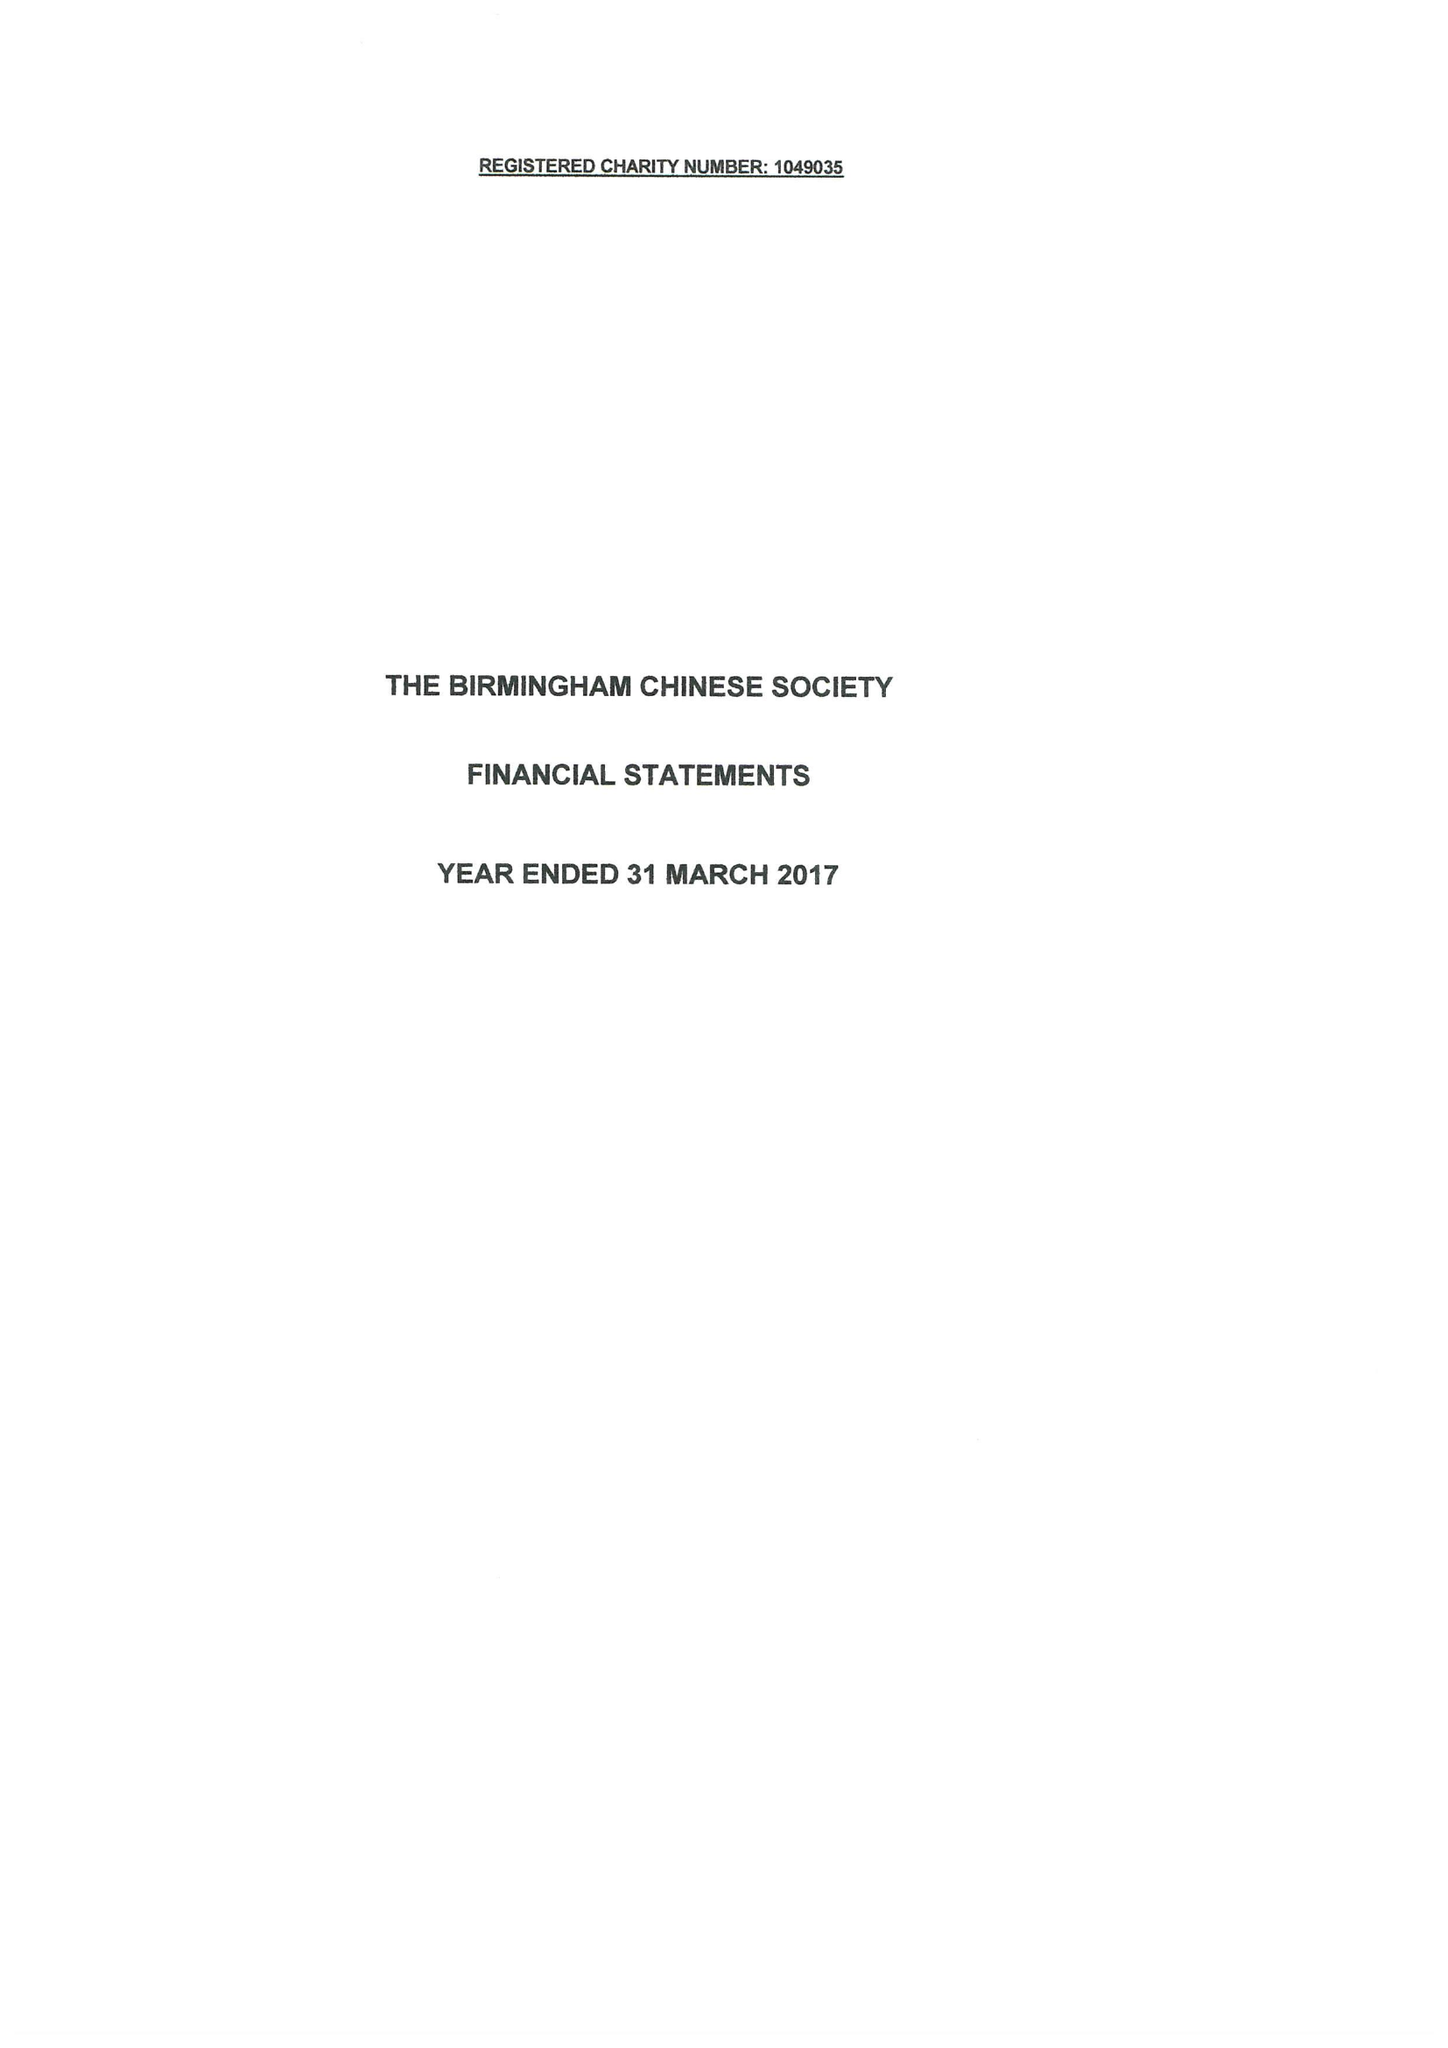What is the value for the spending_annually_in_british_pounds?
Answer the question using a single word or phrase. 47853.00 